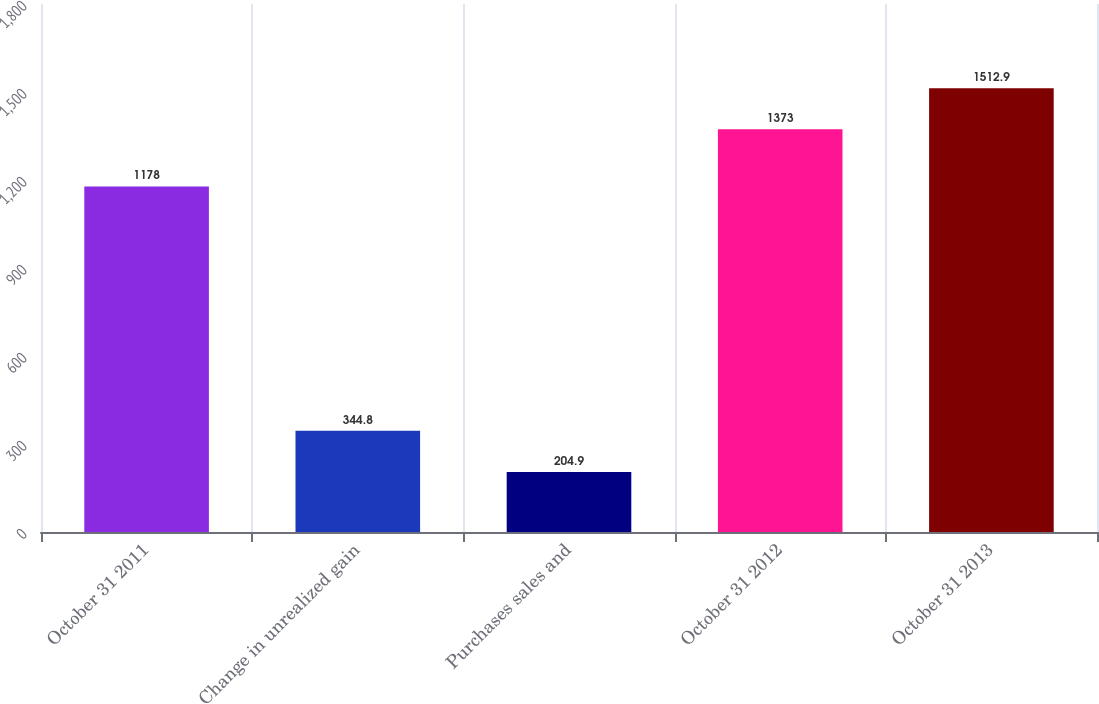Convert chart. <chart><loc_0><loc_0><loc_500><loc_500><bar_chart><fcel>October 31 2011<fcel>Change in unrealized gain<fcel>Purchases sales and<fcel>October 31 2012<fcel>October 31 2013<nl><fcel>1178<fcel>344.8<fcel>204.9<fcel>1373<fcel>1512.9<nl></chart> 